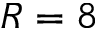Convert formula to latex. <formula><loc_0><loc_0><loc_500><loc_500>R = 8</formula> 